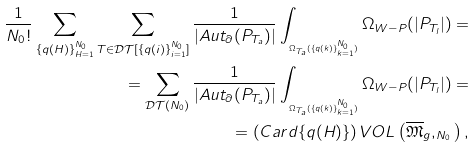Convert formula to latex. <formula><loc_0><loc_0><loc_500><loc_500>\frac { 1 } { N _ { 0 } ! } \sum _ { \{ q ( H ) \} _ { H = 1 } ^ { N _ { 0 } } } \sum _ { T \in \mathcal { D T } [ \{ q ( i ) \} _ { i = 1 } ^ { N _ { 0 } } ] } \frac { 1 } { | A u t _ { \partial } ( P _ { T _ { a } } ) | } \int _ { _ { \Omega _ { T _ { a } } ( \{ q ( k ) \} _ { k = 1 } ^ { N _ { 0 } } ) } } \Omega _ { W - P } ( | P _ { T _ { l } } | ) = \\ = \sum _ { \mathcal { D T } ( N _ { 0 } ) } \frac { 1 } { | A u t _ { \partial } ( P _ { T _ { a } } ) | } \int _ { _ { \Omega _ { T _ { a } } ( \{ q ( k ) \} _ { k = 1 } ^ { N _ { 0 } } ) } } \Omega _ { W - P } ( | P _ { T _ { l } } | ) = \\ = \left ( C a r d \{ q ( H ) \} \right ) V O L \left ( \overline { \mathfrak { M } } _ { g } , _ { N _ { 0 } } \right ) ,</formula> 